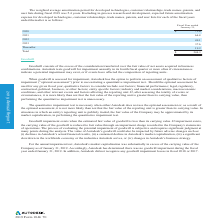According to Autodesk's financial document, What is the estimated economic life of the product? Based on the financial document, the answer is ranges from two to ten years. Also, What was the 2017 expense for developed technologies, customer relationships, trade names, patents, and user lists? Based on the financial document, the answer is $72.2 million. Also, What do the other tangible assets consist of? Based on the financial document, the answer is Developed technologies, at cost. Also, can you calculate: What was the difference in customer relationships, trade names, patents, and user lists, at cost from 2018 to 2019? Based on the calculation: 533.1-372.5 , the result is 160.6 (in millions). The key data points involved are: 372.5, 533.1. Also, can you calculate: What is the increase in net other tangible assets from 2018 to 2019? Based on the calculation: 280.8-55.2, the result is 225.6 (in millions). The key data points involved are: 280.8, 55.2. Also, can you calculate: How much did developed technologies, at cost gain in 2019 over 2018? To answer this question, I need to perform calculations using the financial data. The calculation is: (670.2 -578.5)/578.5 , which equals 15.85 (percentage). The key data points involved are: 578.5, 670.2. 